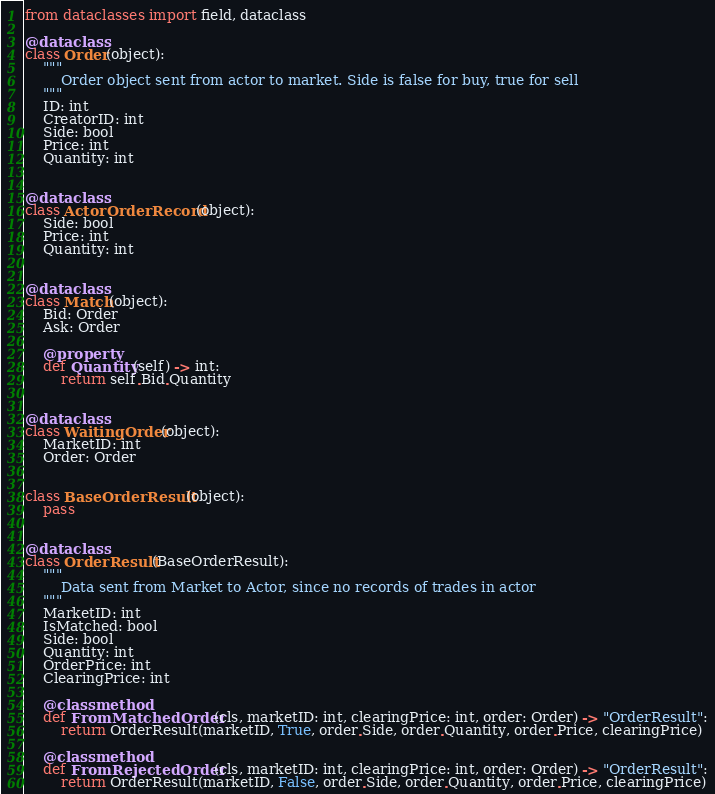<code> <loc_0><loc_0><loc_500><loc_500><_Python_>from dataclasses import field, dataclass

@dataclass
class Order(object):
    """
        Order object sent from actor to market. Side is false for buy, true for sell
    """
    ID: int
    CreatorID: int
    Side: bool
    Price: int
    Quantity: int


@dataclass
class ActorOrderRecord(object):
    Side: bool
    Price: int
    Quantity: int


@dataclass
class Match(object):
    Bid: Order
    Ask: Order

    @property
    def Quantity(self) -> int:
        return self.Bid.Quantity


@dataclass
class WaitingOrder(object):
    MarketID: int
    Order: Order


class BaseOrderResult(object):
    pass


@dataclass
class OrderResult(BaseOrderResult):
    """
        Data sent from Market to Actor, since no records of trades in actor
    """
    MarketID: int
    IsMatched: bool
    Side: bool
    Quantity: int
    OrderPrice: int
    ClearingPrice: int

    @classmethod
    def FromMatchedOrder(cls, marketID: int, clearingPrice: int, order: Order) -> "OrderResult":
        return OrderResult(marketID, True, order.Side, order.Quantity, order.Price, clearingPrice)

    @classmethod
    def FromRejectedOrder(cls, marketID: int, clearingPrice: int, order: Order) -> "OrderResult":
        return OrderResult(marketID, False, order.Side, order.Quantity, order.Price, clearingPrice)
</code> 